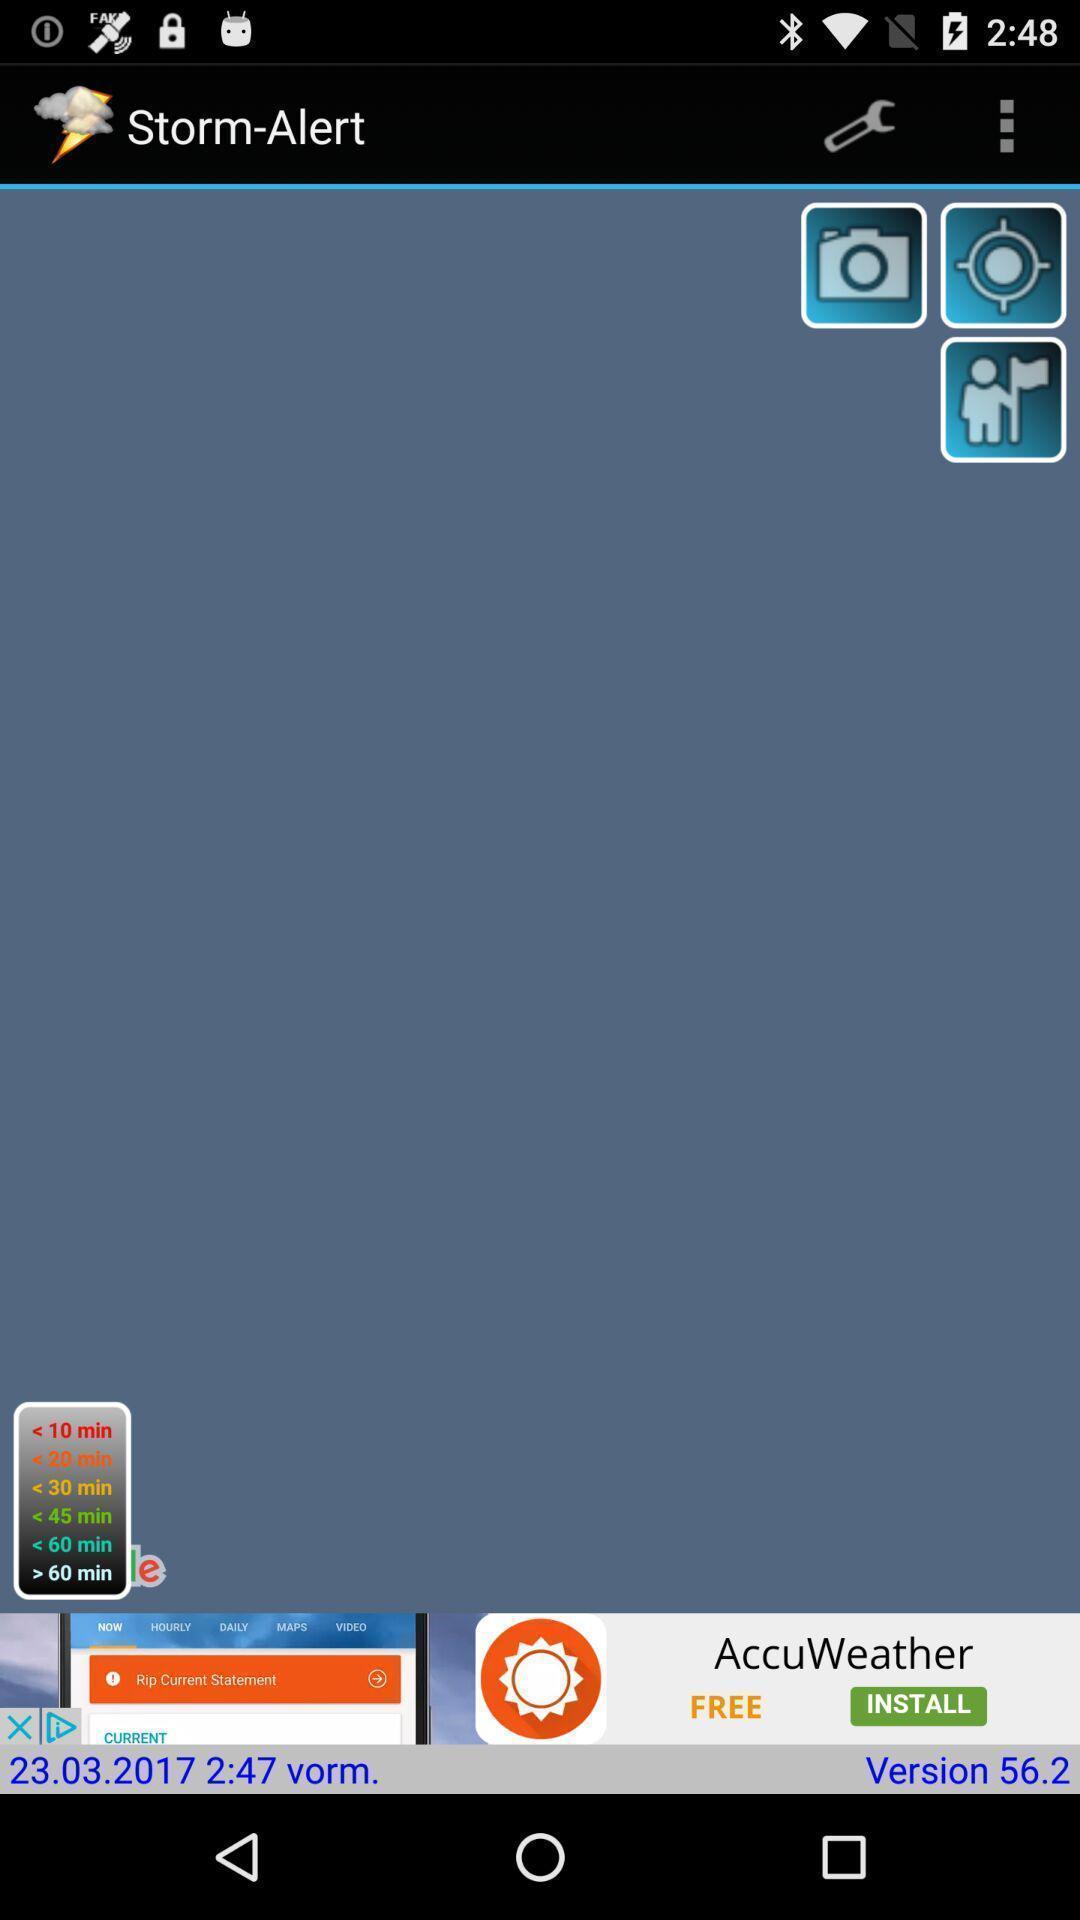Tell me what you see in this picture. Weather application advertisement showing in this page. 